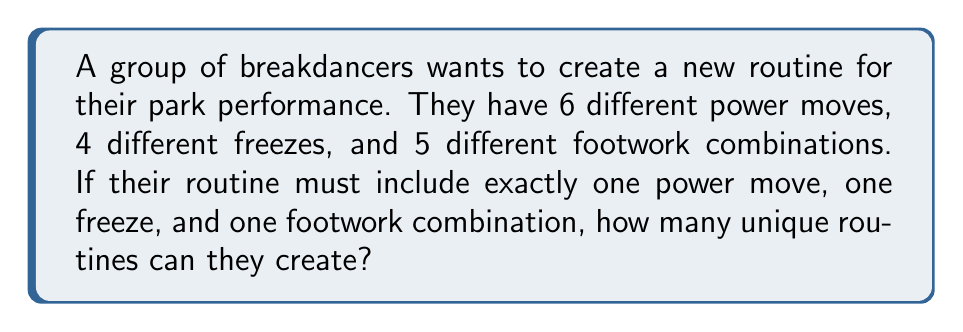What is the answer to this math problem? To solve this problem, we need to use the multiplication principle of counting. This principle states that if we have $m$ ways of doing one thing, and $n$ ways of doing another independent thing, then there are $m \times n$ ways of doing both things.

Let's break down the problem:

1. Power moves: There are 6 options
2. Freezes: There are 4 options
3. Footwork combinations: There are 5 options

For each routine, the dancers must choose:
- One power move out of 6 options
- One freeze out of 4 options
- One footwork combination out of 5 options

Since these choices are independent of each other (the choice of one doesn't affect the choices for the others), we can multiply the number of options for each:

$$ \text{Total number of unique routines} = 6 \times 4 \times 5 $$

Calculating this:

$$ 6 \times 4 \times 5 = 24 \times 5 = 120 $$

Therefore, the breakdancers can create 120 unique routines with their available moves.
Answer: 120 unique routines 